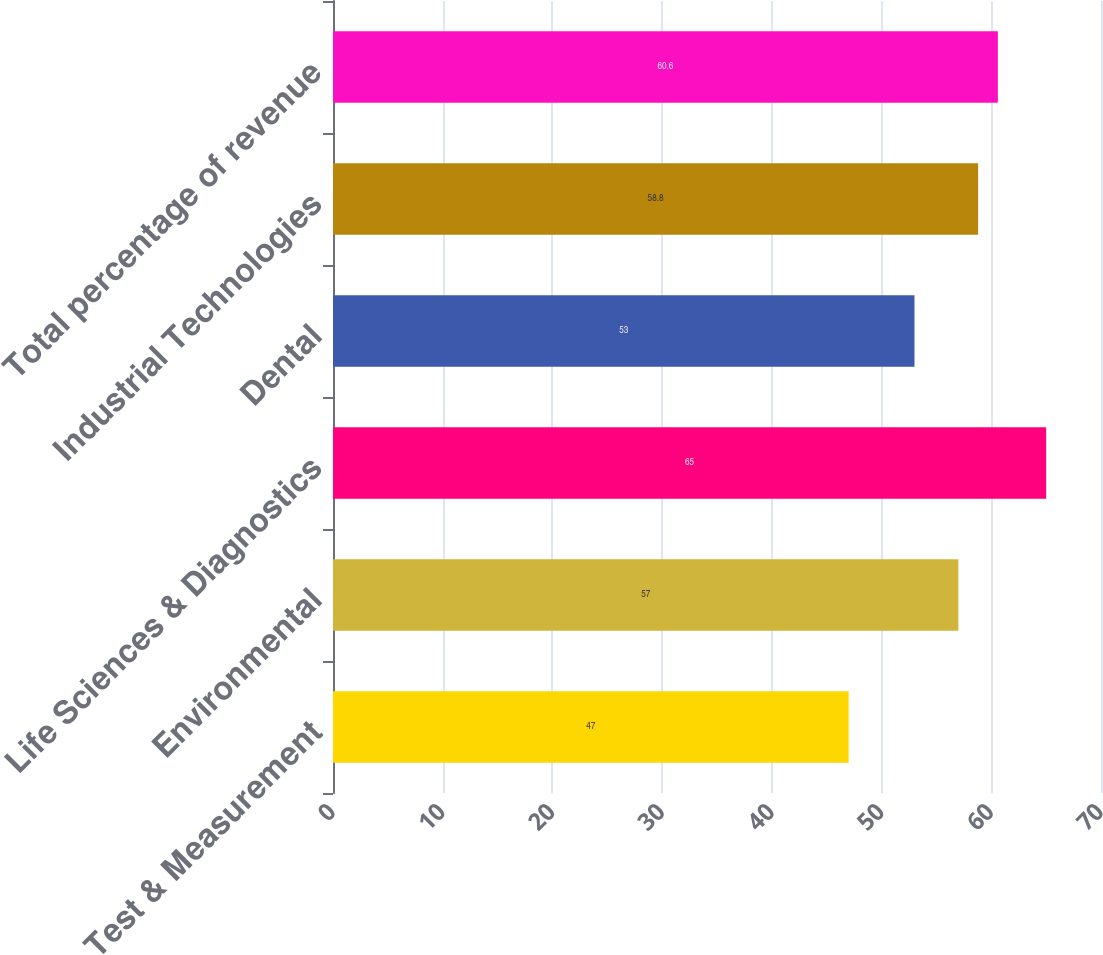<chart> <loc_0><loc_0><loc_500><loc_500><bar_chart><fcel>Test & Measurement<fcel>Environmental<fcel>Life Sciences & Diagnostics<fcel>Dental<fcel>Industrial Technologies<fcel>Total percentage of revenue<nl><fcel>47<fcel>57<fcel>65<fcel>53<fcel>58.8<fcel>60.6<nl></chart> 